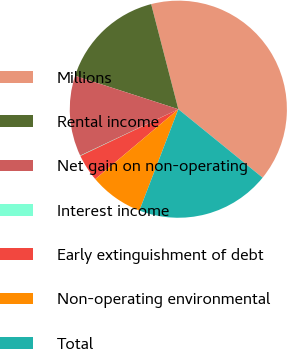<chart> <loc_0><loc_0><loc_500><loc_500><pie_chart><fcel>Millions<fcel>Rental income<fcel>Net gain on non-operating<fcel>Interest income<fcel>Early extinguishment of debt<fcel>Non-operating environmental<fcel>Total<nl><fcel>39.89%<fcel>15.99%<fcel>12.01%<fcel>0.06%<fcel>4.04%<fcel>8.03%<fcel>19.98%<nl></chart> 